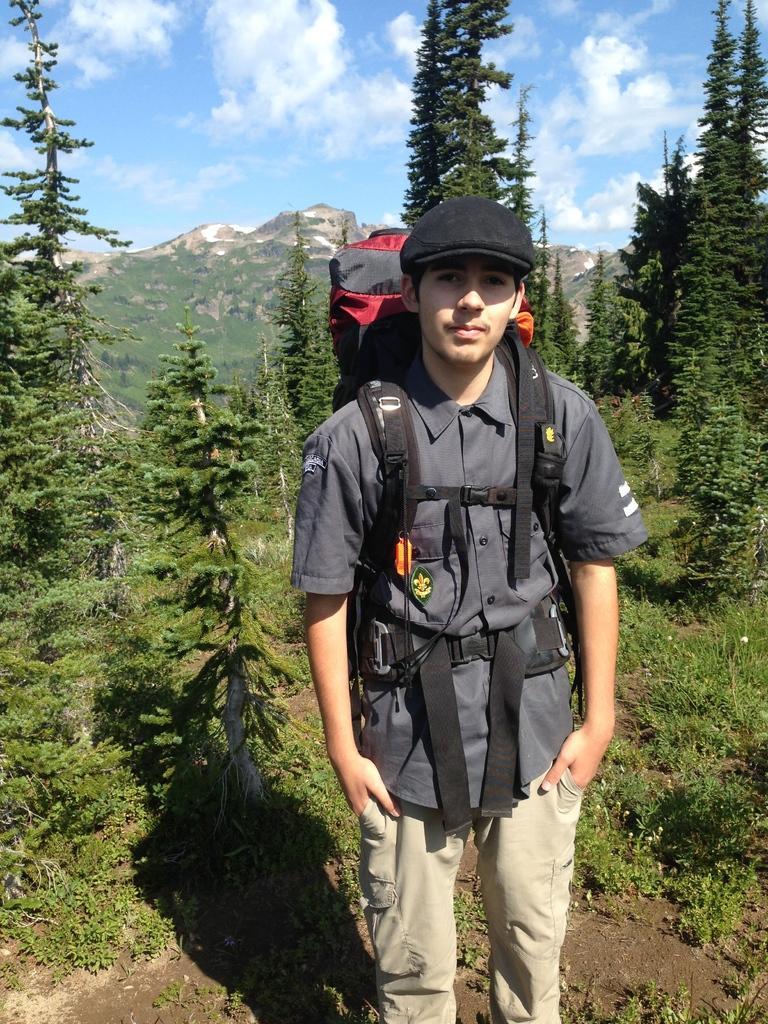How would you summarize this image in a sentence or two? In this image I can see a man wearing shirt, bag and black color cap on his head and standing. In the background I can see some trees. Behind these three there is a hill. On the top of the image I can the sky in blue color and clouds in white color. 